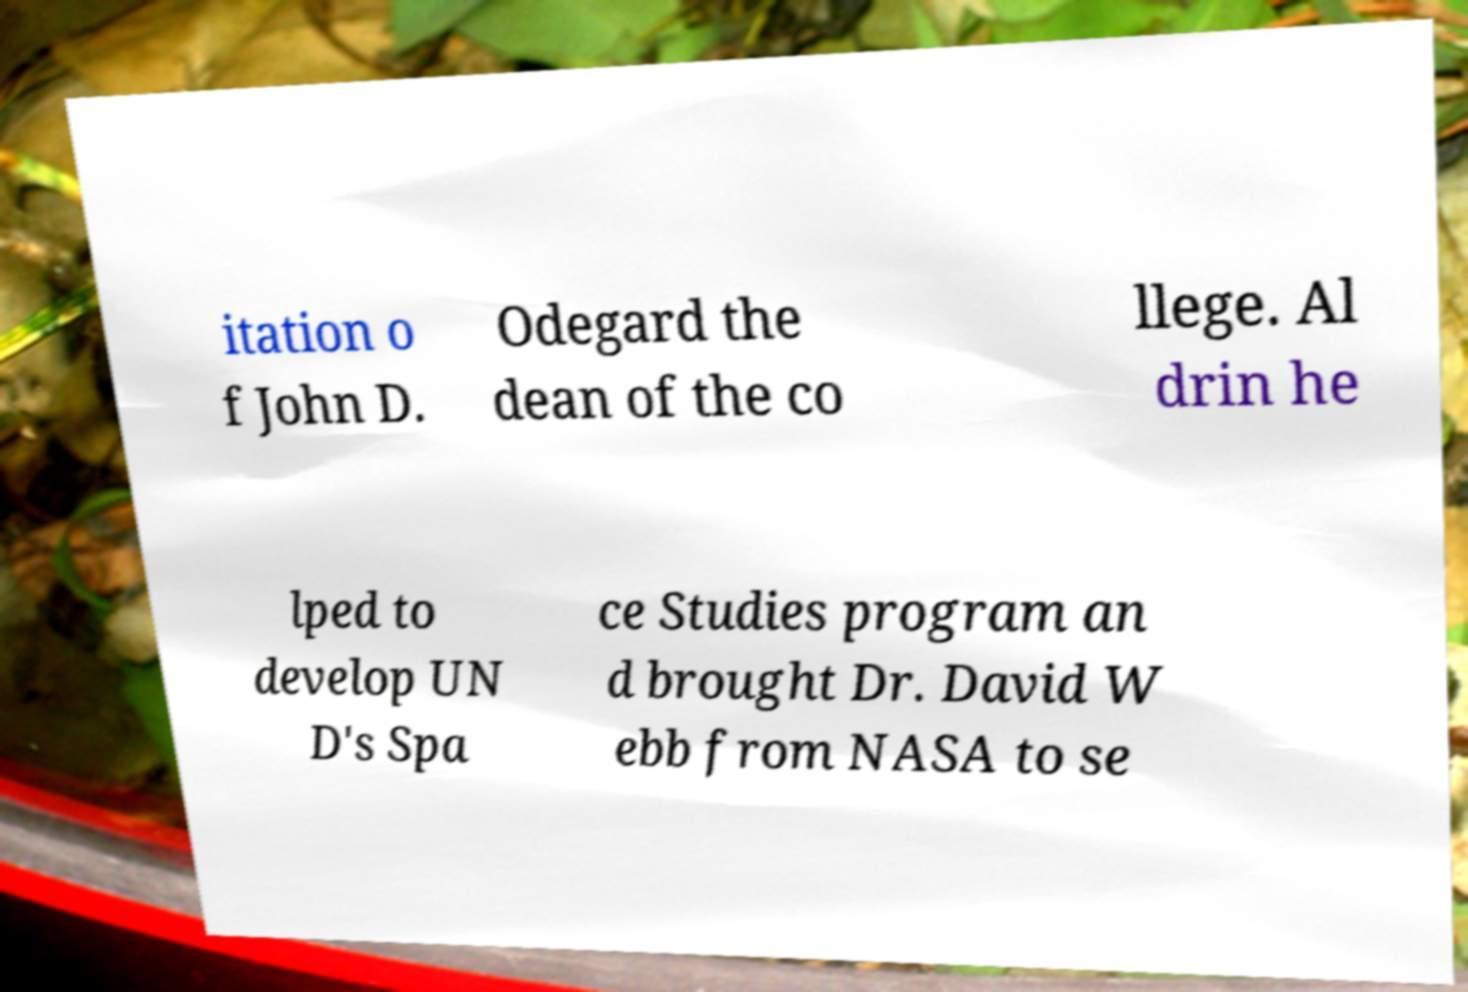Please read and relay the text visible in this image. What does it say? itation o f John D. Odegard the dean of the co llege. Al drin he lped to develop UN D's Spa ce Studies program an d brought Dr. David W ebb from NASA to se 